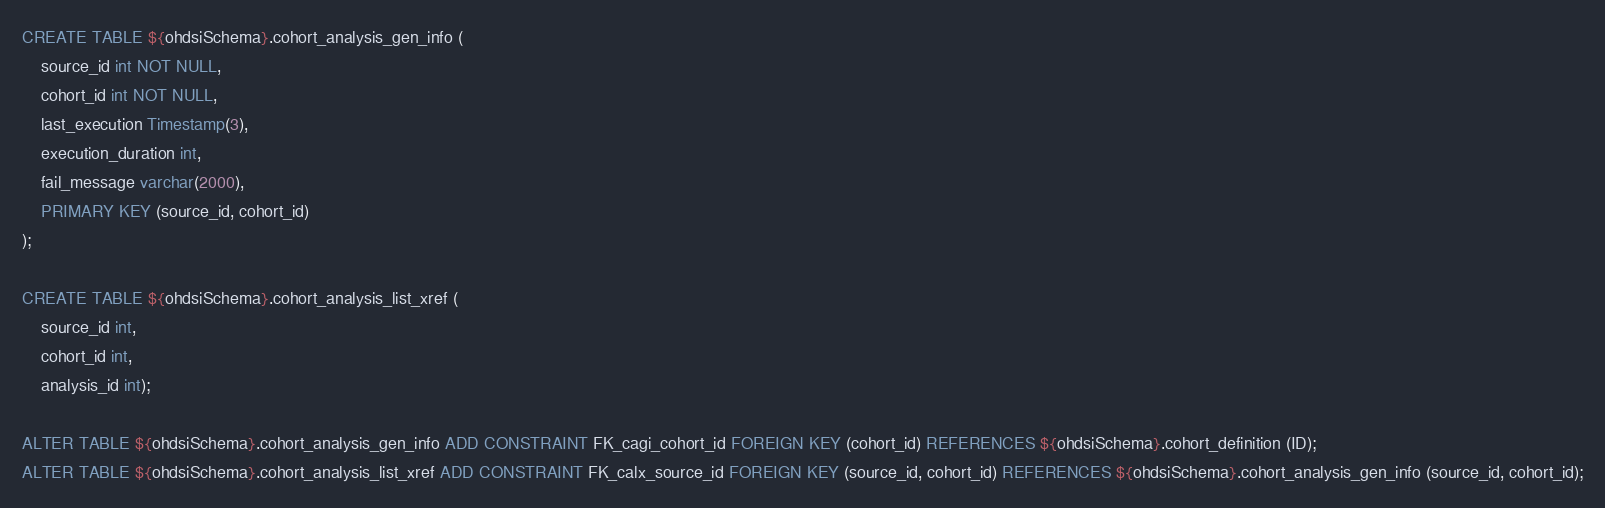Convert code to text. <code><loc_0><loc_0><loc_500><loc_500><_SQL_>CREATE TABLE ${ohdsiSchema}.cohort_analysis_gen_info (
	source_id int NOT NULL, 
	cohort_id int NOT NULL, 
	last_execution Timestamp(3),
	execution_duration int, 
	fail_message varchar(2000), 
	PRIMARY KEY (source_id, cohort_id)
);

CREATE TABLE ${ohdsiSchema}.cohort_analysis_list_xref (
	source_id int, 
	cohort_id int, 
	analysis_id int);

ALTER TABLE ${ohdsiSchema}.cohort_analysis_gen_info ADD CONSTRAINT FK_cagi_cohort_id FOREIGN KEY (cohort_id) REFERENCES ${ohdsiSchema}.cohort_definition (ID);
ALTER TABLE ${ohdsiSchema}.cohort_analysis_list_xref ADD CONSTRAINT FK_calx_source_id FOREIGN KEY (source_id, cohort_id) REFERENCES ${ohdsiSchema}.cohort_analysis_gen_info (source_id, cohort_id);
</code> 